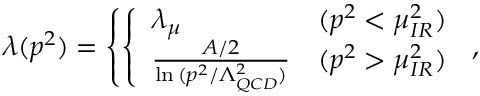<formula> <loc_0><loc_0><loc_500><loc_500>\lambda ( p ^ { 2 } ) = \left \{ \left \{ \begin{array} { l l } { { \lambda _ { \mu } } } & { { ( p ^ { 2 } < \mu _ { I R } ^ { 2 } ) } } \\ { { { \frac { A / 2 } { \ln { ( p ^ { 2 } / \Lambda _ { Q C D } ^ { 2 } ) } } } } } & { { ( p ^ { 2 } > \mu _ { I R } ^ { 2 } ) } } \end{array} ,</formula> 